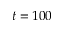Convert formula to latex. <formula><loc_0><loc_0><loc_500><loc_500>t = 1 0 0</formula> 